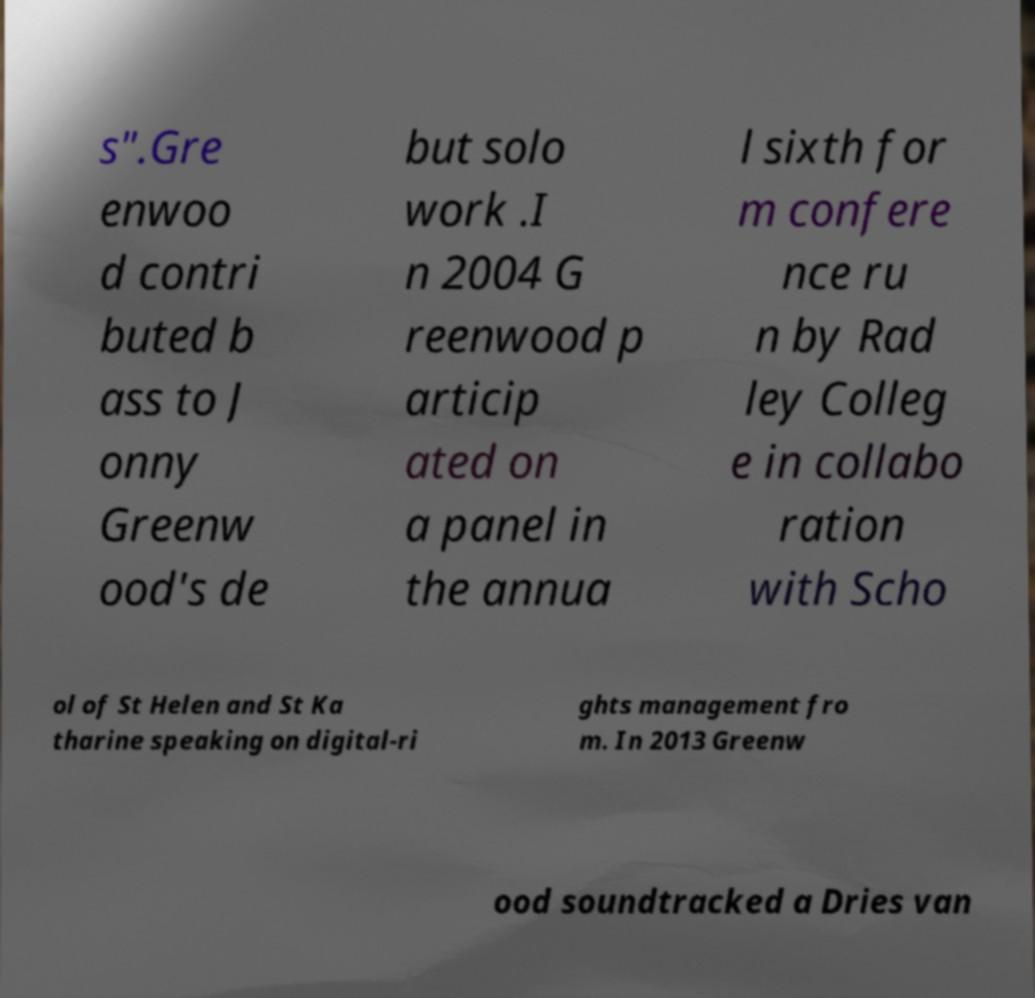What messages or text are displayed in this image? I need them in a readable, typed format. s".Gre enwoo d contri buted b ass to J onny Greenw ood's de but solo work .I n 2004 G reenwood p articip ated on a panel in the annua l sixth for m confere nce ru n by Rad ley Colleg e in collabo ration with Scho ol of St Helen and St Ka tharine speaking on digital-ri ghts management fro m. In 2013 Greenw ood soundtracked a Dries van 